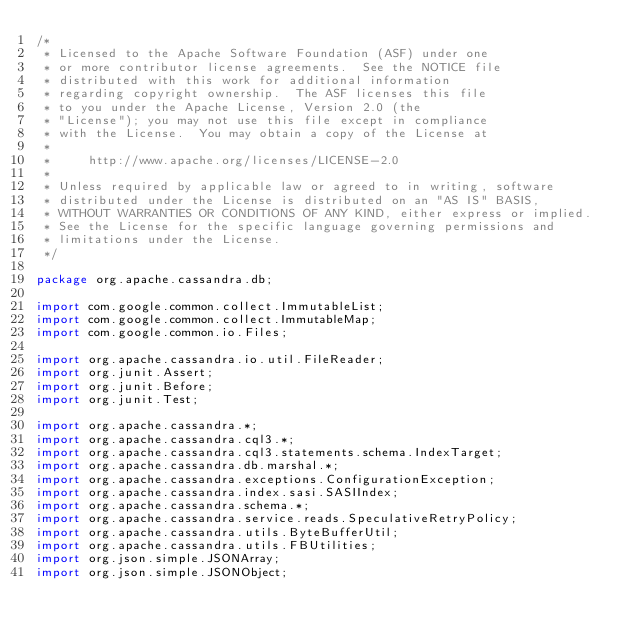Convert code to text. <code><loc_0><loc_0><loc_500><loc_500><_Java_>/*
 * Licensed to the Apache Software Foundation (ASF) under one
 * or more contributor license agreements.  See the NOTICE file
 * distributed with this work for additional information
 * regarding copyright ownership.  The ASF licenses this file
 * to you under the Apache License, Version 2.0 (the
 * "License"); you may not use this file except in compliance
 * with the License.  You may obtain a copy of the License at
 *
 *     http://www.apache.org/licenses/LICENSE-2.0
 *
 * Unless required by applicable law or agreed to in writing, software
 * distributed under the License is distributed on an "AS IS" BASIS,
 * WITHOUT WARRANTIES OR CONDITIONS OF ANY KIND, either express or implied.
 * See the License for the specific language governing permissions and
 * limitations under the License.
 */

package org.apache.cassandra.db;

import com.google.common.collect.ImmutableList;
import com.google.common.collect.ImmutableMap;
import com.google.common.io.Files;

import org.apache.cassandra.io.util.FileReader;
import org.junit.Assert;
import org.junit.Before;
import org.junit.Test;

import org.apache.cassandra.*;
import org.apache.cassandra.cql3.*;
import org.apache.cassandra.cql3.statements.schema.IndexTarget;
import org.apache.cassandra.db.marshal.*;
import org.apache.cassandra.exceptions.ConfigurationException;
import org.apache.cassandra.index.sasi.SASIIndex;
import org.apache.cassandra.schema.*;
import org.apache.cassandra.service.reads.SpeculativeRetryPolicy;
import org.apache.cassandra.utils.ByteBufferUtil;
import org.apache.cassandra.utils.FBUtilities;
import org.json.simple.JSONArray;
import org.json.simple.JSONObject;</code> 